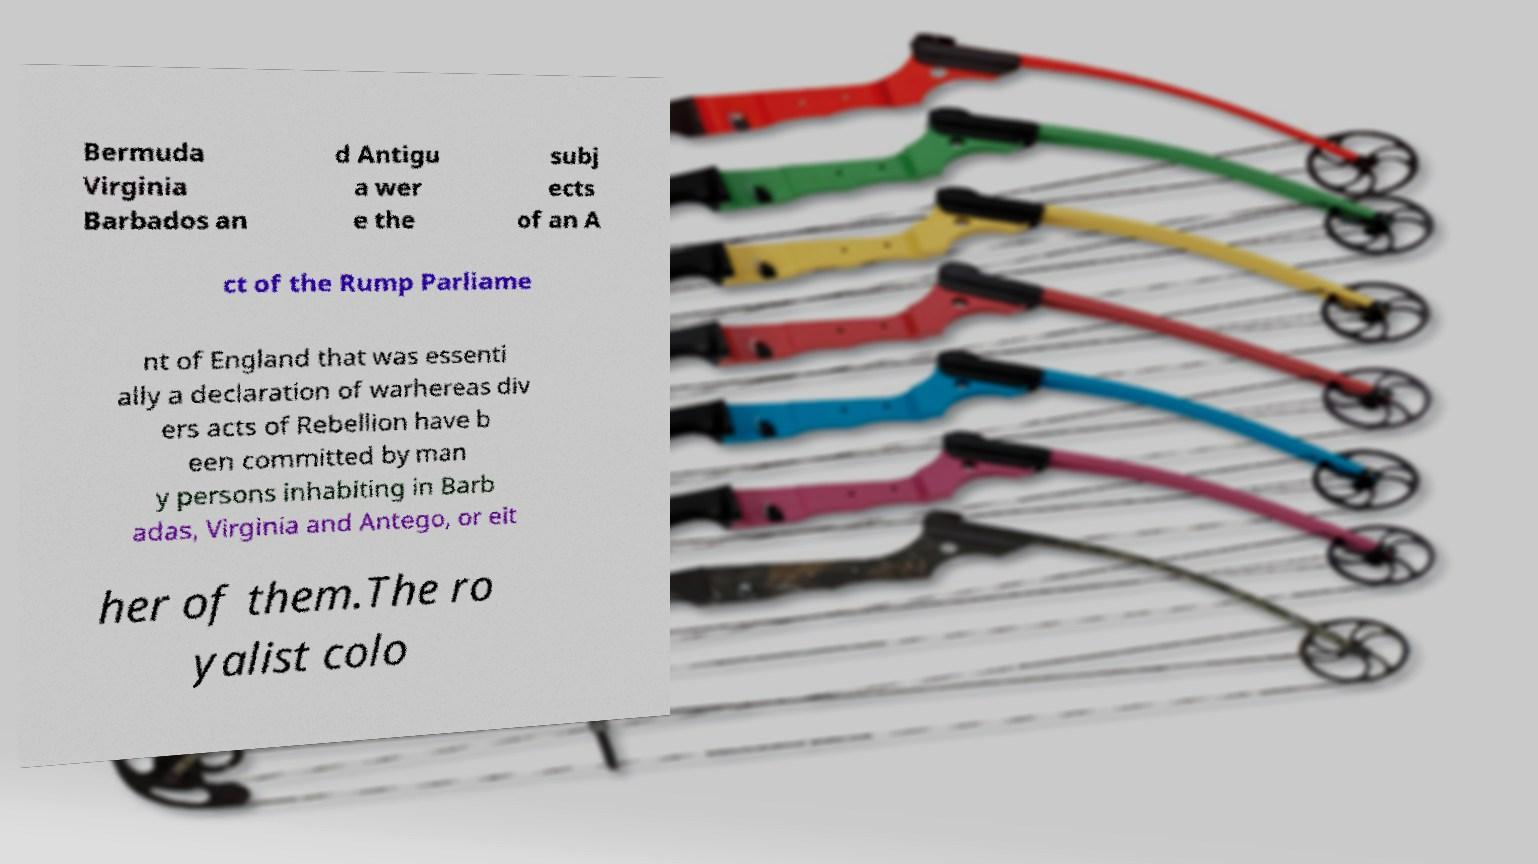Please read and relay the text visible in this image. What does it say? Bermuda Virginia Barbados an d Antigu a wer e the subj ects of an A ct of the Rump Parliame nt of England that was essenti ally a declaration of warhereas div ers acts of Rebellion have b een committed by man y persons inhabiting in Barb adas, Virginia and Antego, or eit her of them.The ro yalist colo 